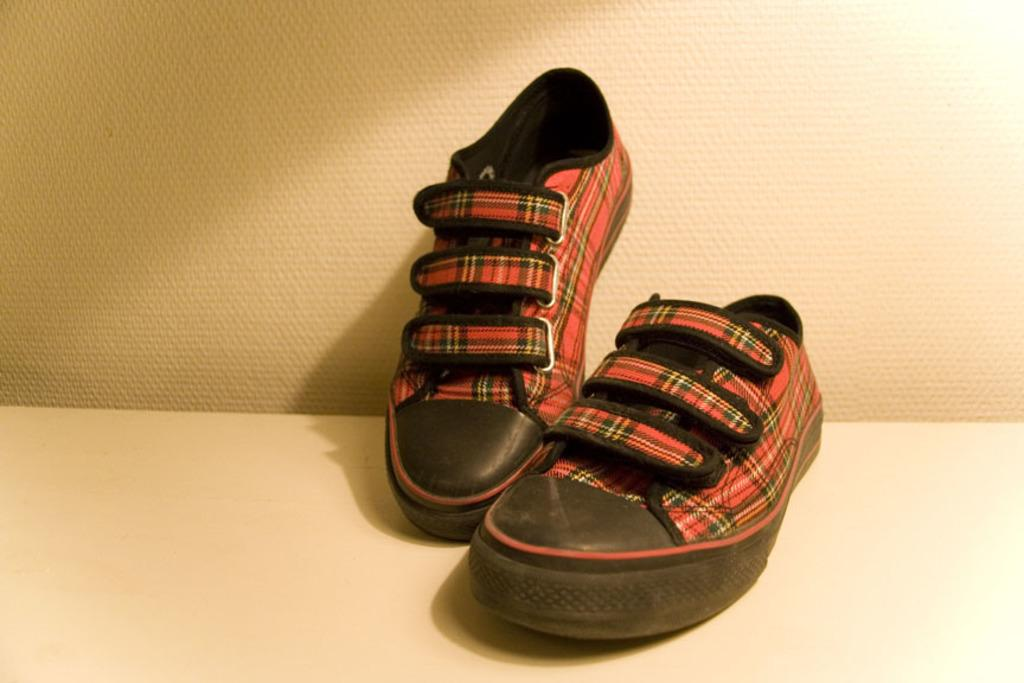What objects are placed on a platform in the image? There are shoes on a platform in the image. What can be seen in the background of the image? There is a wall visible in the background of the image. What type of glue is being used to attach the shoes to the platform in the image? There is no glue present in the image, and the shoes are not attached to the platform. 